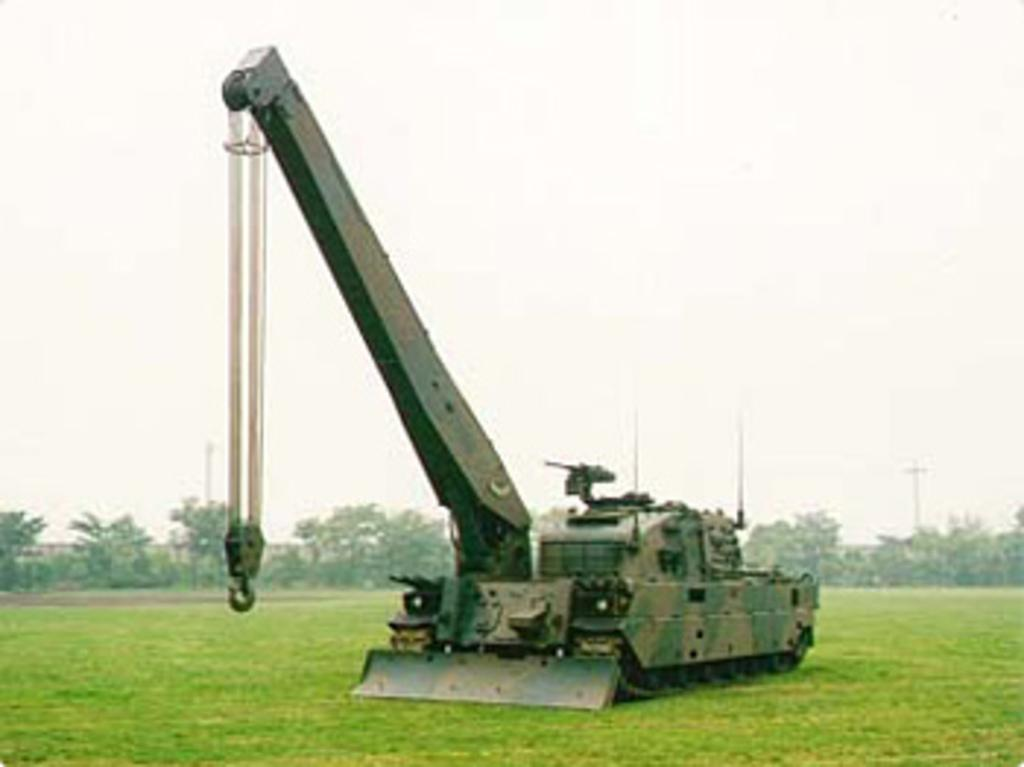What is the main subject of the image? There is a vehicle in the image. What type of terrain is visible in the image? There is grass in the image. What can be seen in the background of the image? There are trees in the background of the image. What is visible at the top of the image? The sky is visible at the top of the image. What type of collar can be seen on the vehicle in the image? There is no collar present on the vehicle in the image. How does the vehicle fall in the image? The vehicle does not fall in the image; it is stationary. 